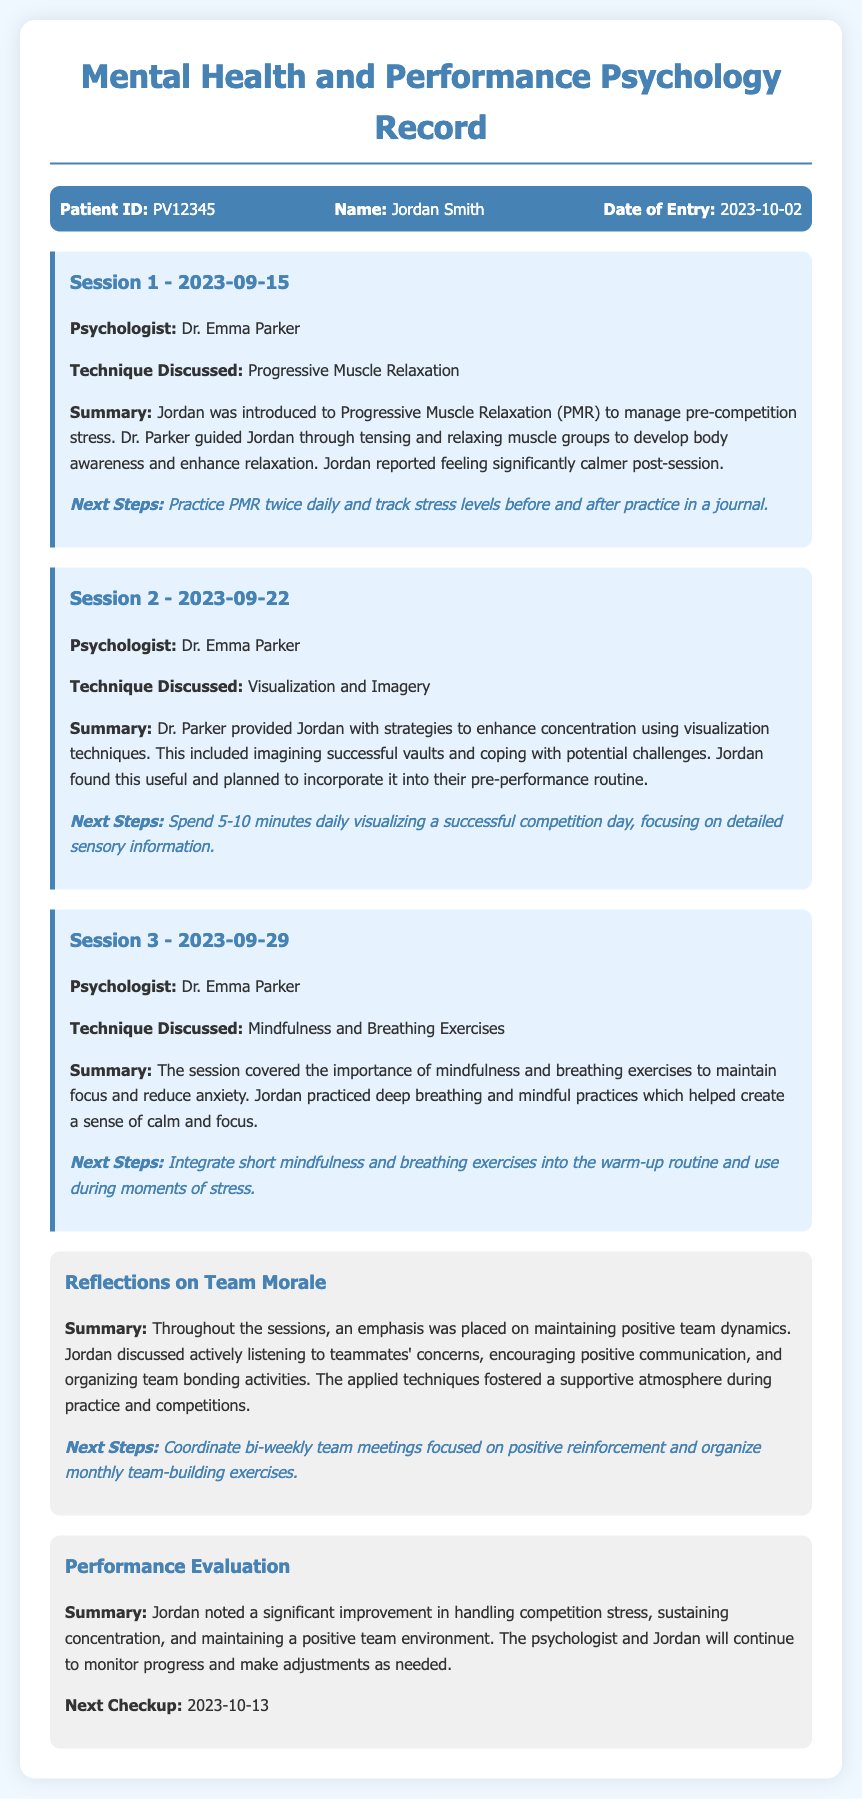What is the patient ID? The patient ID is recorded at the top of the document, which identifies the patient as PV12345.
Answer: PV12345 Who is the psychologist? The psychologist's name is mentioned in each session, identified as Dr. Emma Parker.
Answer: Dr. Emma Parker What technique was discussed in Session 2? The document specifies the techniques discussed in each session, with Session 2 focusing on Visualization and Imagery.
Answer: Visualization and Imagery What was the next step after Session 3? The next step listed pertains to integrating mindfulness and breathing exercises into warm-up routines.
Answer: Integrate short mindfulness and breathing exercises What is the date of the next checkup? The next checkup date is explicitly mentioned in the evaluation section as October 13, 2023.
Answer: 2023-10-13 How did Jordan feel after the first session? The summary of the first session indicates Jordan felt significantly calmer after practicing Progressive Muscle Relaxation.
Answer: Significantly calmer What was the focus of reflections on team morale? The reflections indicate a focus on maintaining positive team dynamics, including listening to concerns and encouraging communication.
Answer: Maintaining positive team dynamics How often will team meetings be coordinated? The next steps state that bi-weekly team meetings focused on positive reinforcement will be coordinated.
Answer: Bi-weekly What improvement did Jordan note? The performance evaluation section notes that Jordan observed a significant improvement in handling competition stress.
Answer: Significant improvement in handling competition stress 